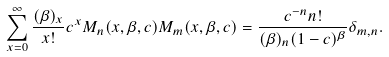<formula> <loc_0><loc_0><loc_500><loc_500>\sum _ { x = 0 } ^ { \infty } \frac { ( \beta ) _ { x } } { x ! } c ^ { x } M _ { n } ( x , \beta , c ) M _ { m } ( x , \beta , c ) = \frac { c ^ { - n } n ! } { ( \beta ) _ { n } ( 1 - c ) ^ { \beta } } \delta _ { m , n } .</formula> 